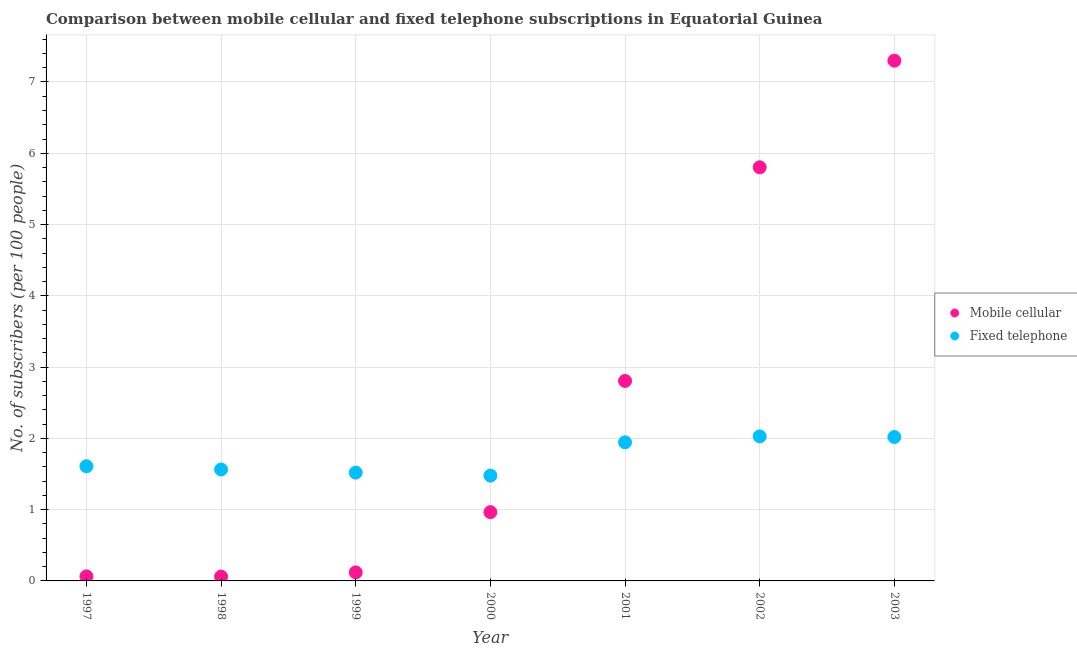How many different coloured dotlines are there?
Give a very brief answer. 2. Is the number of dotlines equal to the number of legend labels?
Provide a short and direct response. Yes. What is the number of mobile cellular subscribers in 1999?
Ensure brevity in your answer.  0.12. Across all years, what is the maximum number of fixed telephone subscribers?
Provide a short and direct response. 2.03. Across all years, what is the minimum number of fixed telephone subscribers?
Your response must be concise. 1.48. In which year was the number of mobile cellular subscribers maximum?
Offer a terse response. 2003. What is the total number of fixed telephone subscribers in the graph?
Offer a terse response. 12.16. What is the difference between the number of mobile cellular subscribers in 1997 and that in 2002?
Your response must be concise. -5.74. What is the difference between the number of fixed telephone subscribers in 2001 and the number of mobile cellular subscribers in 2000?
Keep it short and to the point. 0.98. What is the average number of mobile cellular subscribers per year?
Offer a terse response. 2.45. In the year 2001, what is the difference between the number of mobile cellular subscribers and number of fixed telephone subscribers?
Give a very brief answer. 0.86. What is the ratio of the number of mobile cellular subscribers in 1998 to that in 2001?
Provide a short and direct response. 0.02. Is the difference between the number of fixed telephone subscribers in 1997 and 2002 greater than the difference between the number of mobile cellular subscribers in 1997 and 2002?
Your response must be concise. Yes. What is the difference between the highest and the second highest number of fixed telephone subscribers?
Provide a short and direct response. 0.01. What is the difference between the highest and the lowest number of fixed telephone subscribers?
Ensure brevity in your answer.  0.55. In how many years, is the number of mobile cellular subscribers greater than the average number of mobile cellular subscribers taken over all years?
Provide a short and direct response. 3. How many dotlines are there?
Your answer should be very brief. 2. How many years are there in the graph?
Your answer should be very brief. 7. Are the values on the major ticks of Y-axis written in scientific E-notation?
Your answer should be compact. No. How many legend labels are there?
Ensure brevity in your answer.  2. How are the legend labels stacked?
Give a very brief answer. Vertical. What is the title of the graph?
Offer a terse response. Comparison between mobile cellular and fixed telephone subscriptions in Equatorial Guinea. Does "Primary education" appear as one of the legend labels in the graph?
Give a very brief answer. No. What is the label or title of the X-axis?
Offer a very short reply. Year. What is the label or title of the Y-axis?
Offer a very short reply. No. of subscribers (per 100 people). What is the No. of subscribers (per 100 people) in Mobile cellular in 1997?
Your response must be concise. 0.06. What is the No. of subscribers (per 100 people) in Fixed telephone in 1997?
Provide a succinct answer. 1.61. What is the No. of subscribers (per 100 people) in Mobile cellular in 1998?
Give a very brief answer. 0.06. What is the No. of subscribers (per 100 people) in Fixed telephone in 1998?
Ensure brevity in your answer.  1.56. What is the No. of subscribers (per 100 people) in Mobile cellular in 1999?
Give a very brief answer. 0.12. What is the No. of subscribers (per 100 people) in Fixed telephone in 1999?
Your response must be concise. 1.52. What is the No. of subscribers (per 100 people) in Mobile cellular in 2000?
Your response must be concise. 0.96. What is the No. of subscribers (per 100 people) of Fixed telephone in 2000?
Your response must be concise. 1.48. What is the No. of subscribers (per 100 people) in Mobile cellular in 2001?
Offer a very short reply. 2.81. What is the No. of subscribers (per 100 people) of Fixed telephone in 2001?
Give a very brief answer. 1.94. What is the No. of subscribers (per 100 people) of Mobile cellular in 2002?
Make the answer very short. 5.8. What is the No. of subscribers (per 100 people) of Fixed telephone in 2002?
Make the answer very short. 2.03. What is the No. of subscribers (per 100 people) in Mobile cellular in 2003?
Ensure brevity in your answer.  7.3. What is the No. of subscribers (per 100 people) of Fixed telephone in 2003?
Ensure brevity in your answer.  2.02. Across all years, what is the maximum No. of subscribers (per 100 people) in Mobile cellular?
Make the answer very short. 7.3. Across all years, what is the maximum No. of subscribers (per 100 people) of Fixed telephone?
Give a very brief answer. 2.03. Across all years, what is the minimum No. of subscribers (per 100 people) in Mobile cellular?
Provide a succinct answer. 0.06. Across all years, what is the minimum No. of subscribers (per 100 people) in Fixed telephone?
Your response must be concise. 1.48. What is the total No. of subscribers (per 100 people) of Mobile cellular in the graph?
Your answer should be compact. 17.12. What is the total No. of subscribers (per 100 people) of Fixed telephone in the graph?
Your answer should be very brief. 12.16. What is the difference between the No. of subscribers (per 100 people) in Mobile cellular in 1997 and that in 1998?
Provide a succinct answer. 0. What is the difference between the No. of subscribers (per 100 people) of Fixed telephone in 1997 and that in 1998?
Ensure brevity in your answer.  0.05. What is the difference between the No. of subscribers (per 100 people) of Mobile cellular in 1997 and that in 1999?
Your answer should be very brief. -0.06. What is the difference between the No. of subscribers (per 100 people) of Fixed telephone in 1997 and that in 1999?
Ensure brevity in your answer.  0.09. What is the difference between the No. of subscribers (per 100 people) of Mobile cellular in 1997 and that in 2000?
Your response must be concise. -0.9. What is the difference between the No. of subscribers (per 100 people) of Fixed telephone in 1997 and that in 2000?
Provide a short and direct response. 0.13. What is the difference between the No. of subscribers (per 100 people) of Mobile cellular in 1997 and that in 2001?
Provide a short and direct response. -2.74. What is the difference between the No. of subscribers (per 100 people) of Fixed telephone in 1997 and that in 2001?
Give a very brief answer. -0.34. What is the difference between the No. of subscribers (per 100 people) of Mobile cellular in 1997 and that in 2002?
Provide a succinct answer. -5.74. What is the difference between the No. of subscribers (per 100 people) in Fixed telephone in 1997 and that in 2002?
Offer a very short reply. -0.42. What is the difference between the No. of subscribers (per 100 people) of Mobile cellular in 1997 and that in 2003?
Provide a short and direct response. -7.24. What is the difference between the No. of subscribers (per 100 people) in Fixed telephone in 1997 and that in 2003?
Offer a terse response. -0.41. What is the difference between the No. of subscribers (per 100 people) in Mobile cellular in 1998 and that in 1999?
Your answer should be very brief. -0.06. What is the difference between the No. of subscribers (per 100 people) of Fixed telephone in 1998 and that in 1999?
Keep it short and to the point. 0.04. What is the difference between the No. of subscribers (per 100 people) in Mobile cellular in 1998 and that in 2000?
Offer a terse response. -0.9. What is the difference between the No. of subscribers (per 100 people) in Fixed telephone in 1998 and that in 2000?
Keep it short and to the point. 0.09. What is the difference between the No. of subscribers (per 100 people) of Mobile cellular in 1998 and that in 2001?
Offer a terse response. -2.74. What is the difference between the No. of subscribers (per 100 people) of Fixed telephone in 1998 and that in 2001?
Your answer should be very brief. -0.38. What is the difference between the No. of subscribers (per 100 people) in Mobile cellular in 1998 and that in 2002?
Ensure brevity in your answer.  -5.74. What is the difference between the No. of subscribers (per 100 people) in Fixed telephone in 1998 and that in 2002?
Keep it short and to the point. -0.46. What is the difference between the No. of subscribers (per 100 people) in Mobile cellular in 1998 and that in 2003?
Ensure brevity in your answer.  -7.24. What is the difference between the No. of subscribers (per 100 people) in Fixed telephone in 1998 and that in 2003?
Keep it short and to the point. -0.46. What is the difference between the No. of subscribers (per 100 people) in Mobile cellular in 1999 and that in 2000?
Keep it short and to the point. -0.85. What is the difference between the No. of subscribers (per 100 people) in Fixed telephone in 1999 and that in 2000?
Your answer should be compact. 0.04. What is the difference between the No. of subscribers (per 100 people) of Mobile cellular in 1999 and that in 2001?
Your answer should be very brief. -2.69. What is the difference between the No. of subscribers (per 100 people) in Fixed telephone in 1999 and that in 2001?
Ensure brevity in your answer.  -0.42. What is the difference between the No. of subscribers (per 100 people) of Mobile cellular in 1999 and that in 2002?
Your answer should be compact. -5.68. What is the difference between the No. of subscribers (per 100 people) of Fixed telephone in 1999 and that in 2002?
Offer a very short reply. -0.51. What is the difference between the No. of subscribers (per 100 people) in Mobile cellular in 1999 and that in 2003?
Give a very brief answer. -7.18. What is the difference between the No. of subscribers (per 100 people) in Fixed telephone in 1999 and that in 2003?
Make the answer very short. -0.5. What is the difference between the No. of subscribers (per 100 people) in Mobile cellular in 2000 and that in 2001?
Provide a short and direct response. -1.84. What is the difference between the No. of subscribers (per 100 people) in Fixed telephone in 2000 and that in 2001?
Ensure brevity in your answer.  -0.47. What is the difference between the No. of subscribers (per 100 people) of Mobile cellular in 2000 and that in 2002?
Offer a terse response. -4.84. What is the difference between the No. of subscribers (per 100 people) in Fixed telephone in 2000 and that in 2002?
Ensure brevity in your answer.  -0.55. What is the difference between the No. of subscribers (per 100 people) in Mobile cellular in 2000 and that in 2003?
Provide a succinct answer. -6.33. What is the difference between the No. of subscribers (per 100 people) of Fixed telephone in 2000 and that in 2003?
Give a very brief answer. -0.54. What is the difference between the No. of subscribers (per 100 people) in Mobile cellular in 2001 and that in 2002?
Offer a very short reply. -3. What is the difference between the No. of subscribers (per 100 people) of Fixed telephone in 2001 and that in 2002?
Make the answer very short. -0.08. What is the difference between the No. of subscribers (per 100 people) in Mobile cellular in 2001 and that in 2003?
Offer a terse response. -4.49. What is the difference between the No. of subscribers (per 100 people) in Fixed telephone in 2001 and that in 2003?
Keep it short and to the point. -0.07. What is the difference between the No. of subscribers (per 100 people) in Mobile cellular in 2002 and that in 2003?
Give a very brief answer. -1.5. What is the difference between the No. of subscribers (per 100 people) in Fixed telephone in 2002 and that in 2003?
Provide a succinct answer. 0.01. What is the difference between the No. of subscribers (per 100 people) of Mobile cellular in 1997 and the No. of subscribers (per 100 people) of Fixed telephone in 1998?
Make the answer very short. -1.5. What is the difference between the No. of subscribers (per 100 people) of Mobile cellular in 1997 and the No. of subscribers (per 100 people) of Fixed telephone in 1999?
Make the answer very short. -1.46. What is the difference between the No. of subscribers (per 100 people) of Mobile cellular in 1997 and the No. of subscribers (per 100 people) of Fixed telephone in 2000?
Provide a succinct answer. -1.41. What is the difference between the No. of subscribers (per 100 people) in Mobile cellular in 1997 and the No. of subscribers (per 100 people) in Fixed telephone in 2001?
Provide a short and direct response. -1.88. What is the difference between the No. of subscribers (per 100 people) of Mobile cellular in 1997 and the No. of subscribers (per 100 people) of Fixed telephone in 2002?
Your answer should be compact. -1.96. What is the difference between the No. of subscribers (per 100 people) in Mobile cellular in 1997 and the No. of subscribers (per 100 people) in Fixed telephone in 2003?
Offer a terse response. -1.96. What is the difference between the No. of subscribers (per 100 people) in Mobile cellular in 1998 and the No. of subscribers (per 100 people) in Fixed telephone in 1999?
Give a very brief answer. -1.46. What is the difference between the No. of subscribers (per 100 people) of Mobile cellular in 1998 and the No. of subscribers (per 100 people) of Fixed telephone in 2000?
Your answer should be very brief. -1.42. What is the difference between the No. of subscribers (per 100 people) in Mobile cellular in 1998 and the No. of subscribers (per 100 people) in Fixed telephone in 2001?
Your answer should be compact. -1.88. What is the difference between the No. of subscribers (per 100 people) in Mobile cellular in 1998 and the No. of subscribers (per 100 people) in Fixed telephone in 2002?
Provide a succinct answer. -1.97. What is the difference between the No. of subscribers (per 100 people) of Mobile cellular in 1998 and the No. of subscribers (per 100 people) of Fixed telephone in 2003?
Your answer should be very brief. -1.96. What is the difference between the No. of subscribers (per 100 people) of Mobile cellular in 1999 and the No. of subscribers (per 100 people) of Fixed telephone in 2000?
Provide a succinct answer. -1.36. What is the difference between the No. of subscribers (per 100 people) in Mobile cellular in 1999 and the No. of subscribers (per 100 people) in Fixed telephone in 2001?
Offer a very short reply. -1.82. What is the difference between the No. of subscribers (per 100 people) in Mobile cellular in 1999 and the No. of subscribers (per 100 people) in Fixed telephone in 2002?
Your answer should be compact. -1.91. What is the difference between the No. of subscribers (per 100 people) of Mobile cellular in 1999 and the No. of subscribers (per 100 people) of Fixed telephone in 2003?
Give a very brief answer. -1.9. What is the difference between the No. of subscribers (per 100 people) of Mobile cellular in 2000 and the No. of subscribers (per 100 people) of Fixed telephone in 2001?
Give a very brief answer. -0.98. What is the difference between the No. of subscribers (per 100 people) in Mobile cellular in 2000 and the No. of subscribers (per 100 people) in Fixed telephone in 2002?
Your response must be concise. -1.06. What is the difference between the No. of subscribers (per 100 people) of Mobile cellular in 2000 and the No. of subscribers (per 100 people) of Fixed telephone in 2003?
Offer a very short reply. -1.05. What is the difference between the No. of subscribers (per 100 people) of Mobile cellular in 2001 and the No. of subscribers (per 100 people) of Fixed telephone in 2002?
Make the answer very short. 0.78. What is the difference between the No. of subscribers (per 100 people) of Mobile cellular in 2001 and the No. of subscribers (per 100 people) of Fixed telephone in 2003?
Keep it short and to the point. 0.79. What is the difference between the No. of subscribers (per 100 people) of Mobile cellular in 2002 and the No. of subscribers (per 100 people) of Fixed telephone in 2003?
Give a very brief answer. 3.78. What is the average No. of subscribers (per 100 people) in Mobile cellular per year?
Your answer should be very brief. 2.45. What is the average No. of subscribers (per 100 people) in Fixed telephone per year?
Give a very brief answer. 1.74. In the year 1997, what is the difference between the No. of subscribers (per 100 people) in Mobile cellular and No. of subscribers (per 100 people) in Fixed telephone?
Your answer should be very brief. -1.55. In the year 1998, what is the difference between the No. of subscribers (per 100 people) in Mobile cellular and No. of subscribers (per 100 people) in Fixed telephone?
Ensure brevity in your answer.  -1.5. In the year 1999, what is the difference between the No. of subscribers (per 100 people) in Mobile cellular and No. of subscribers (per 100 people) in Fixed telephone?
Ensure brevity in your answer.  -1.4. In the year 2000, what is the difference between the No. of subscribers (per 100 people) of Mobile cellular and No. of subscribers (per 100 people) of Fixed telephone?
Your response must be concise. -0.51. In the year 2001, what is the difference between the No. of subscribers (per 100 people) of Mobile cellular and No. of subscribers (per 100 people) of Fixed telephone?
Ensure brevity in your answer.  0.86. In the year 2002, what is the difference between the No. of subscribers (per 100 people) of Mobile cellular and No. of subscribers (per 100 people) of Fixed telephone?
Provide a succinct answer. 3.78. In the year 2003, what is the difference between the No. of subscribers (per 100 people) of Mobile cellular and No. of subscribers (per 100 people) of Fixed telephone?
Offer a very short reply. 5.28. What is the ratio of the No. of subscribers (per 100 people) in Mobile cellular in 1997 to that in 1998?
Offer a very short reply. 1.04. What is the ratio of the No. of subscribers (per 100 people) in Fixed telephone in 1997 to that in 1998?
Provide a succinct answer. 1.03. What is the ratio of the No. of subscribers (per 100 people) in Mobile cellular in 1997 to that in 1999?
Your response must be concise. 0.53. What is the ratio of the No. of subscribers (per 100 people) in Fixed telephone in 1997 to that in 1999?
Give a very brief answer. 1.06. What is the ratio of the No. of subscribers (per 100 people) in Mobile cellular in 1997 to that in 2000?
Provide a succinct answer. 0.07. What is the ratio of the No. of subscribers (per 100 people) of Fixed telephone in 1997 to that in 2000?
Your answer should be compact. 1.09. What is the ratio of the No. of subscribers (per 100 people) in Mobile cellular in 1997 to that in 2001?
Provide a succinct answer. 0.02. What is the ratio of the No. of subscribers (per 100 people) of Fixed telephone in 1997 to that in 2001?
Keep it short and to the point. 0.83. What is the ratio of the No. of subscribers (per 100 people) in Mobile cellular in 1997 to that in 2002?
Keep it short and to the point. 0.01. What is the ratio of the No. of subscribers (per 100 people) in Fixed telephone in 1997 to that in 2002?
Give a very brief answer. 0.79. What is the ratio of the No. of subscribers (per 100 people) of Mobile cellular in 1997 to that in 2003?
Provide a succinct answer. 0.01. What is the ratio of the No. of subscribers (per 100 people) in Fixed telephone in 1997 to that in 2003?
Provide a succinct answer. 0.8. What is the ratio of the No. of subscribers (per 100 people) in Mobile cellular in 1998 to that in 1999?
Give a very brief answer. 0.51. What is the ratio of the No. of subscribers (per 100 people) of Fixed telephone in 1998 to that in 1999?
Ensure brevity in your answer.  1.03. What is the ratio of the No. of subscribers (per 100 people) in Mobile cellular in 1998 to that in 2000?
Your response must be concise. 0.06. What is the ratio of the No. of subscribers (per 100 people) of Fixed telephone in 1998 to that in 2000?
Offer a very short reply. 1.06. What is the ratio of the No. of subscribers (per 100 people) in Mobile cellular in 1998 to that in 2001?
Your answer should be compact. 0.02. What is the ratio of the No. of subscribers (per 100 people) of Fixed telephone in 1998 to that in 2001?
Provide a short and direct response. 0.8. What is the ratio of the No. of subscribers (per 100 people) in Mobile cellular in 1998 to that in 2002?
Offer a very short reply. 0.01. What is the ratio of the No. of subscribers (per 100 people) in Fixed telephone in 1998 to that in 2002?
Ensure brevity in your answer.  0.77. What is the ratio of the No. of subscribers (per 100 people) of Mobile cellular in 1998 to that in 2003?
Offer a very short reply. 0.01. What is the ratio of the No. of subscribers (per 100 people) of Fixed telephone in 1998 to that in 2003?
Give a very brief answer. 0.77. What is the ratio of the No. of subscribers (per 100 people) in Mobile cellular in 1999 to that in 2000?
Your response must be concise. 0.12. What is the ratio of the No. of subscribers (per 100 people) in Fixed telephone in 1999 to that in 2000?
Offer a terse response. 1.03. What is the ratio of the No. of subscribers (per 100 people) in Mobile cellular in 1999 to that in 2001?
Offer a very short reply. 0.04. What is the ratio of the No. of subscribers (per 100 people) in Fixed telephone in 1999 to that in 2001?
Keep it short and to the point. 0.78. What is the ratio of the No. of subscribers (per 100 people) in Mobile cellular in 1999 to that in 2002?
Keep it short and to the point. 0.02. What is the ratio of the No. of subscribers (per 100 people) of Fixed telephone in 1999 to that in 2002?
Offer a terse response. 0.75. What is the ratio of the No. of subscribers (per 100 people) in Mobile cellular in 1999 to that in 2003?
Give a very brief answer. 0.02. What is the ratio of the No. of subscribers (per 100 people) of Fixed telephone in 1999 to that in 2003?
Your answer should be compact. 0.75. What is the ratio of the No. of subscribers (per 100 people) in Mobile cellular in 2000 to that in 2001?
Your response must be concise. 0.34. What is the ratio of the No. of subscribers (per 100 people) in Fixed telephone in 2000 to that in 2001?
Your answer should be compact. 0.76. What is the ratio of the No. of subscribers (per 100 people) of Mobile cellular in 2000 to that in 2002?
Provide a succinct answer. 0.17. What is the ratio of the No. of subscribers (per 100 people) of Fixed telephone in 2000 to that in 2002?
Give a very brief answer. 0.73. What is the ratio of the No. of subscribers (per 100 people) in Mobile cellular in 2000 to that in 2003?
Offer a terse response. 0.13. What is the ratio of the No. of subscribers (per 100 people) in Fixed telephone in 2000 to that in 2003?
Your response must be concise. 0.73. What is the ratio of the No. of subscribers (per 100 people) of Mobile cellular in 2001 to that in 2002?
Ensure brevity in your answer.  0.48. What is the ratio of the No. of subscribers (per 100 people) of Fixed telephone in 2001 to that in 2002?
Give a very brief answer. 0.96. What is the ratio of the No. of subscribers (per 100 people) of Mobile cellular in 2001 to that in 2003?
Ensure brevity in your answer.  0.38. What is the ratio of the No. of subscribers (per 100 people) of Fixed telephone in 2001 to that in 2003?
Your response must be concise. 0.96. What is the ratio of the No. of subscribers (per 100 people) in Mobile cellular in 2002 to that in 2003?
Offer a very short reply. 0.8. What is the difference between the highest and the second highest No. of subscribers (per 100 people) in Mobile cellular?
Make the answer very short. 1.5. What is the difference between the highest and the second highest No. of subscribers (per 100 people) in Fixed telephone?
Your answer should be compact. 0.01. What is the difference between the highest and the lowest No. of subscribers (per 100 people) of Mobile cellular?
Your response must be concise. 7.24. What is the difference between the highest and the lowest No. of subscribers (per 100 people) of Fixed telephone?
Provide a succinct answer. 0.55. 